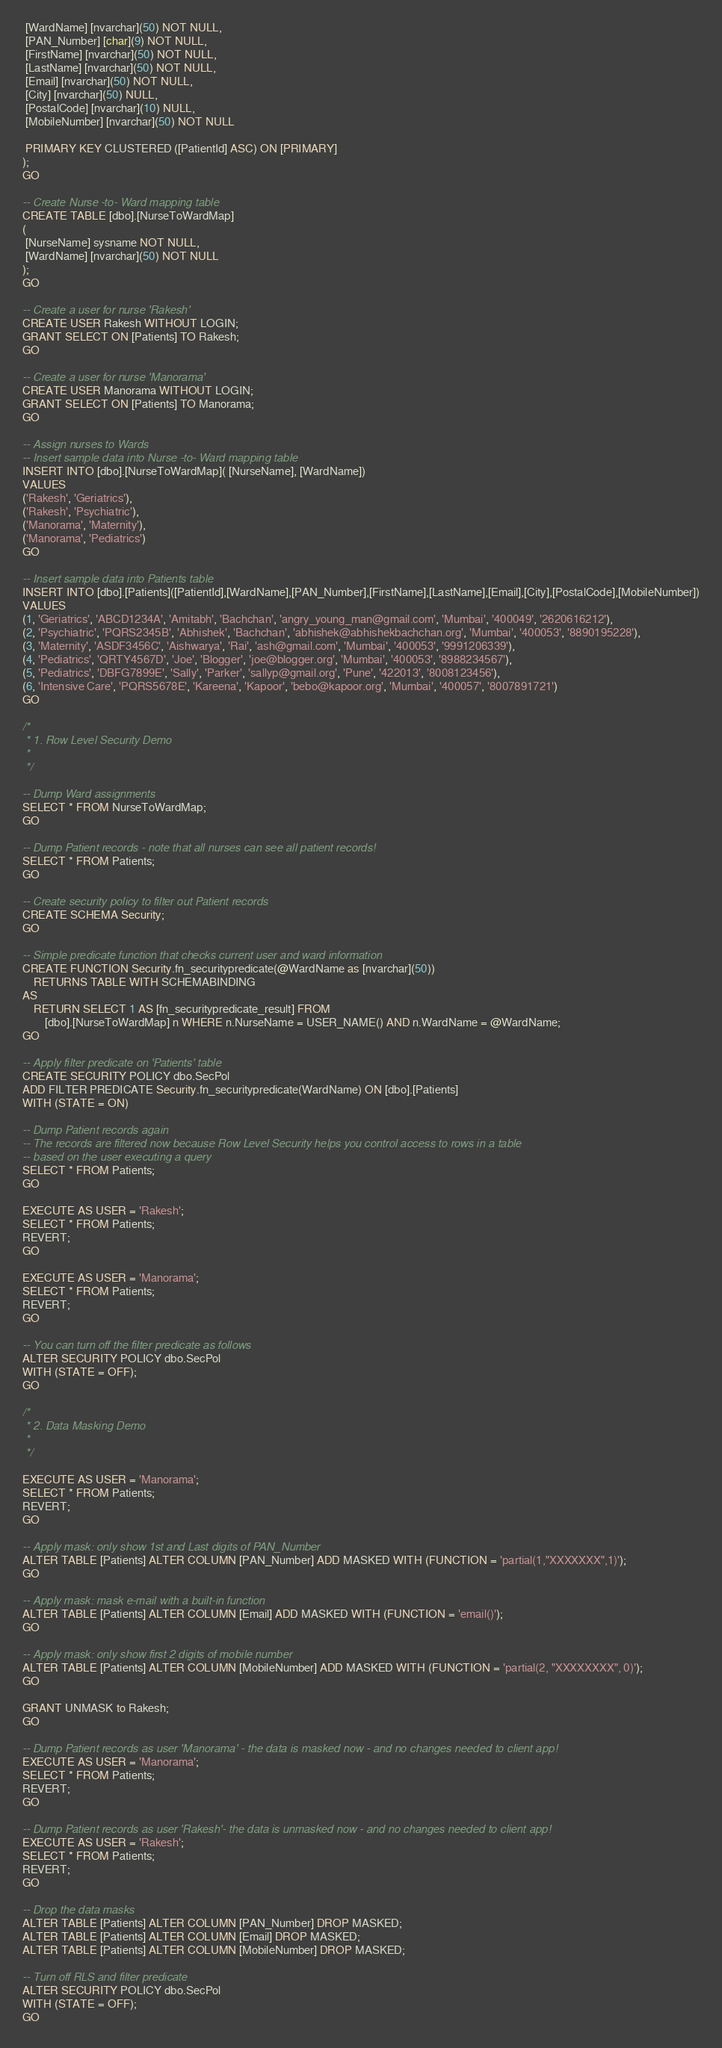Convert code to text. <code><loc_0><loc_0><loc_500><loc_500><_SQL_> [WardName] [nvarchar](50) NOT NULL,
 [PAN_Number] [char](9) NOT NULL,
 [FirstName] [nvarchar](50) NOT NULL,
 [LastName] [nvarchar](50) NOT NULL,
 [Email] [nvarchar](50) NOT NULL,
 [City] [nvarchar](50) NULL,
 [PostalCode] [nvarchar](10) NULL,
 [MobileNumber] [nvarchar](50) NOT NULL

 PRIMARY KEY CLUSTERED ([PatientId] ASC) ON [PRIMARY]
);
GO

-- Create Nurse -to- Ward mapping table
CREATE TABLE [dbo].[NurseToWardMap]
(
 [NurseName] sysname NOT NULL,
 [WardName] [nvarchar](50) NOT NULL
);
GO

-- Create a user for nurse 'Rakesh'
CREATE USER Rakesh WITHOUT LOGIN;
GRANT SELECT ON [Patients] TO Rakesh;
GO

-- Create a user for nurse 'Manorama'
CREATE USER Manorama WITHOUT LOGIN;
GRANT SELECT ON [Patients] TO Manorama;
GO

-- Assign nurses to Wards
-- Insert sample data into Nurse -to- Ward mapping table
INSERT INTO [dbo].[NurseToWardMap]( [NurseName], [WardName])
VALUES
('Rakesh', 'Geriatrics'),
('Rakesh', 'Psychiatric'),
('Manorama', 'Maternity'),
('Manorama', 'Pediatrics')
GO

-- Insert sample data into Patients table
INSERT INTO [dbo].[Patients]([PatientId],[WardName],[PAN_Number],[FirstName],[LastName],[Email],[City],[PostalCode],[MobileNumber])
VALUES
(1, 'Geriatrics', 'ABCD1234A', 'Amitabh', 'Bachchan', 'angry_young_man@gmail.com', 'Mumbai', '400049', '2620616212'),
(2, 'Psychiatric', 'PQRS2345B', 'Abhishek', 'Bachchan', 'abhishek@abhishekbachchan.org', 'Mumbai', '400053', '8890195228'),
(3, 'Maternity', 'ASDF3456C', 'Aishwarya', 'Rai', 'ash@gmail.com', 'Mumbai', '400053', '9991206339'),
(4, 'Pediatrics', 'QRTY4567D', 'Joe', 'Blogger', 'joe@blogger.org', 'Mumbai', '400053', '8988234567'),
(5, 'Pediatrics', 'DBFG7899E', 'Sally', 'Parker', 'sallyp@gmail.org', 'Pune', '422013', '8008123456'),
(6, 'Intensive Care', 'PQRS5678E', 'Kareena', 'Kapoor', 'bebo@kapoor.org', 'Mumbai', '400057', '8007891721')
GO

/*
 * 1. Row Level Security Demo
 *
 */

-- Dump Ward assignments
SELECT * FROM NurseToWardMap;
GO

-- Dump Patient records - note that all nurses can see all patient records!
SELECT * FROM Patients;
GO

-- Create security policy to filter out Patient records
CREATE SCHEMA Security;
GO

-- Simple predicate function that checks current user and ward information
CREATE FUNCTION Security.fn_securitypredicate(@WardName as [nvarchar](50))
	RETURNS TABLE WITH SCHEMABINDING
AS
	RETURN SELECT 1 AS [fn_securitypredicate_result] FROM
		[dbo].[NurseToWardMap] n WHERE n.NurseName = USER_NAME() AND n.WardName = @WardName;
GO

-- Apply filter predicate on 'Patients' table
CREATE SECURITY POLICY dbo.SecPol
ADD FILTER PREDICATE Security.fn_securitypredicate(WardName) ON [dbo].[Patients]
WITH (STATE = ON)

-- Dump Patient records again
-- The records are filtered now because Row Level Security helps you control access to rows in a table
-- based on the user executing a query
SELECT * FROM Patients;
GO

EXECUTE AS USER = 'Rakesh';
SELECT * FROM Patients;
REVERT;
GO

EXECUTE AS USER = 'Manorama';
SELECT * FROM Patients;
REVERT;
GO

-- You can turn off the filter predicate as follows
ALTER SECURITY POLICY dbo.SecPol
WITH (STATE = OFF);
GO

/*
 * 2. Data Masking Demo
 *
 */

EXECUTE AS USER = 'Manorama';
SELECT * FROM Patients;
REVERT;
GO

-- Apply mask: only show 1st and Last digits of PAN_Number
ALTER TABLE [Patients] ALTER COLUMN [PAN_Number] ADD MASKED WITH (FUNCTION = 'partial(1,"XXXXXXX",1)');
GO

-- Apply mask: mask e-mail with a built-in function
ALTER TABLE [Patients] ALTER COLUMN [Email] ADD MASKED WITH (FUNCTION = 'email()');
GO

-- Apply mask: only show first 2 digits of mobile number
ALTER TABLE [Patients] ALTER COLUMN [MobileNumber] ADD MASKED WITH (FUNCTION = 'partial(2, "XXXXXXXX", 0)');
GO

GRANT UNMASK to Rakesh;
GO

-- Dump Patient records as user 'Manorama' - the data is masked now - and no changes needed to client app!
EXECUTE AS USER = 'Manorama';
SELECT * FROM Patients;
REVERT;
GO

-- Dump Patient records as user 'Rakesh'- the data is unmasked now - and no changes needed to client app!
EXECUTE AS USER = 'Rakesh';
SELECT * FROM Patients;
REVERT;
GO

-- Drop the data masks
ALTER TABLE [Patients] ALTER COLUMN [PAN_Number] DROP MASKED;
ALTER TABLE [Patients] ALTER COLUMN [Email] DROP MASKED;
ALTER TABLE [Patients] ALTER COLUMN [MobileNumber] DROP MASKED;

-- Turn off RLS and filter predicate
ALTER SECURITY POLICY dbo.SecPol
WITH (STATE = OFF);
GO</code> 